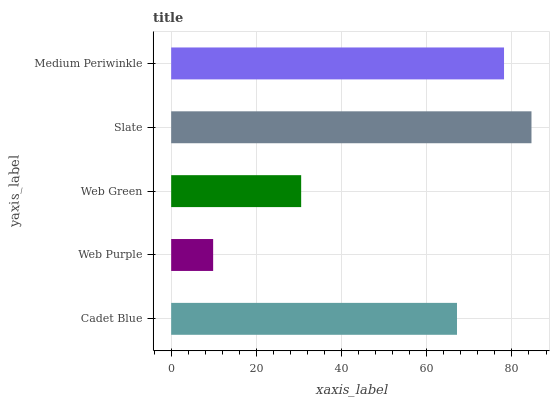Is Web Purple the minimum?
Answer yes or no. Yes. Is Slate the maximum?
Answer yes or no. Yes. Is Web Green the minimum?
Answer yes or no. No. Is Web Green the maximum?
Answer yes or no. No. Is Web Green greater than Web Purple?
Answer yes or no. Yes. Is Web Purple less than Web Green?
Answer yes or no. Yes. Is Web Purple greater than Web Green?
Answer yes or no. No. Is Web Green less than Web Purple?
Answer yes or no. No. Is Cadet Blue the high median?
Answer yes or no. Yes. Is Cadet Blue the low median?
Answer yes or no. Yes. Is Slate the high median?
Answer yes or no. No. Is Medium Periwinkle the low median?
Answer yes or no. No. 